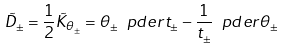<formula> <loc_0><loc_0><loc_500><loc_500>\tilde { D } _ { \pm } = \frac { 1 } { 2 } \tilde { K } _ { \theta _ { \pm } } = \theta _ { \pm } \ p d e r { t _ { \pm } } - \frac { 1 } { t _ { \pm } } \ p d e r { \theta _ { \pm } }</formula> 